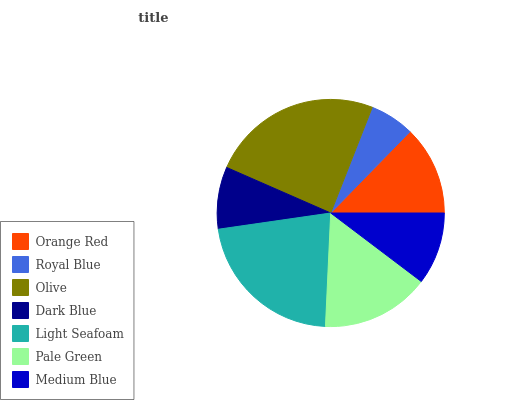Is Royal Blue the minimum?
Answer yes or no. Yes. Is Olive the maximum?
Answer yes or no. Yes. Is Olive the minimum?
Answer yes or no. No. Is Royal Blue the maximum?
Answer yes or no. No. Is Olive greater than Royal Blue?
Answer yes or no. Yes. Is Royal Blue less than Olive?
Answer yes or no. Yes. Is Royal Blue greater than Olive?
Answer yes or no. No. Is Olive less than Royal Blue?
Answer yes or no. No. Is Orange Red the high median?
Answer yes or no. Yes. Is Orange Red the low median?
Answer yes or no. Yes. Is Pale Green the high median?
Answer yes or no. No. Is Olive the low median?
Answer yes or no. No. 